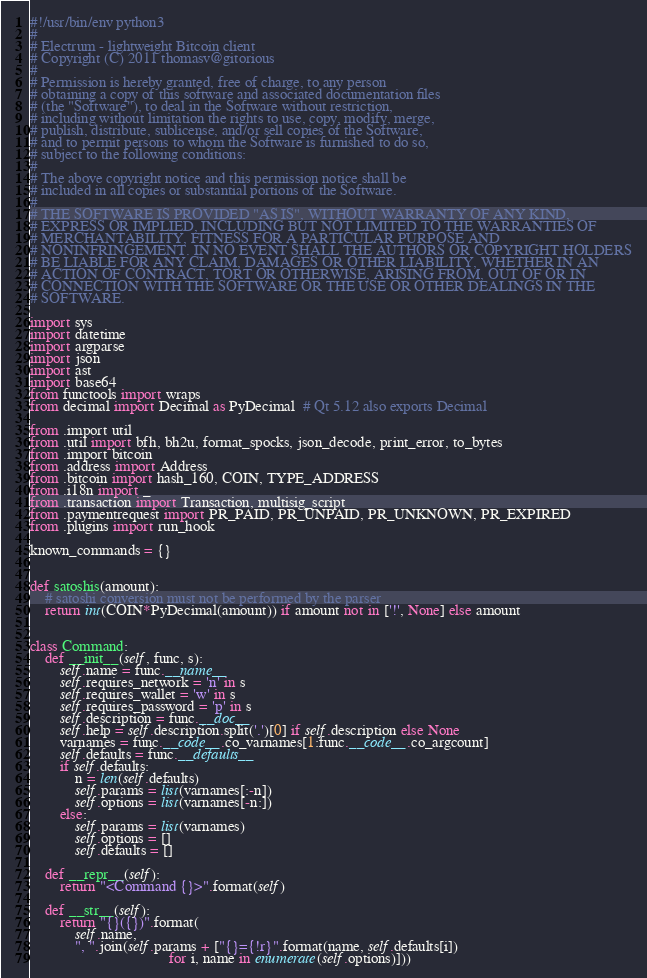<code> <loc_0><loc_0><loc_500><loc_500><_Python_>#!/usr/bin/env python3
#
# Electrum - lightweight Bitcoin client
# Copyright (C) 2011 thomasv@gitorious
#
# Permission is hereby granted, free of charge, to any person
# obtaining a copy of this software and associated documentation files
# (the "Software"), to deal in the Software without restriction,
# including without limitation the rights to use, copy, modify, merge,
# publish, distribute, sublicense, and/or sell copies of the Software,
# and to permit persons to whom the Software is furnished to do so,
# subject to the following conditions:
#
# The above copyright notice and this permission notice shall be
# included in all copies or substantial portions of the Software.
#
# THE SOFTWARE IS PROVIDED "AS IS", WITHOUT WARRANTY OF ANY KIND,
# EXPRESS OR IMPLIED, INCLUDING BUT NOT LIMITED TO THE WARRANTIES OF
# MERCHANTABILITY, FITNESS FOR A PARTICULAR PURPOSE AND
# NONINFRINGEMENT. IN NO EVENT SHALL THE AUTHORS OR COPYRIGHT HOLDERS
# BE LIABLE FOR ANY CLAIM, DAMAGES OR OTHER LIABILITY, WHETHER IN AN
# ACTION OF CONTRACT, TORT OR OTHERWISE, ARISING FROM, OUT OF OR IN
# CONNECTION WITH THE SOFTWARE OR THE USE OR OTHER DEALINGS IN THE
# SOFTWARE.

import sys
import datetime
import argparse
import json
import ast
import base64
from functools import wraps
from decimal import Decimal as PyDecimal  # Qt 5.12 also exports Decimal

from .import util
from .util import bfh, bh2u, format_spocks, json_decode, print_error, to_bytes
from .import bitcoin
from .address import Address
from .bitcoin import hash_160, COIN, TYPE_ADDRESS
from .i18n import _
from .transaction import Transaction, multisig_script
from .paymentrequest import PR_PAID, PR_UNPAID, PR_UNKNOWN, PR_EXPIRED
from .plugins import run_hook

known_commands = {}


def satoshis(amount):
    # satoshi conversion must not be performed by the parser
    return int(COIN*PyDecimal(amount)) if amount not in ['!', None] else amount


class Command:
    def __init__(self, func, s):
        self.name = func.__name__
        self.requires_network = 'n' in s
        self.requires_wallet = 'w' in s
        self.requires_password = 'p' in s
        self.description = func.__doc__
        self.help = self.description.split('.')[0] if self.description else None
        varnames = func.__code__.co_varnames[1:func.__code__.co_argcount]
        self.defaults = func.__defaults__
        if self.defaults:
            n = len(self.defaults)
            self.params = list(varnames[:-n])
            self.options = list(varnames[-n:])
        else:
            self.params = list(varnames)
            self.options = []
            self.defaults = []

    def __repr__(self):
        return "<Command {}>".format(self)

    def __str__(self):
        return "{}({})".format(
            self.name,
            ", ".join(self.params + ["{}={!r}".format(name, self.defaults[i])
                                     for i, name in enumerate(self.options)]))

</code> 